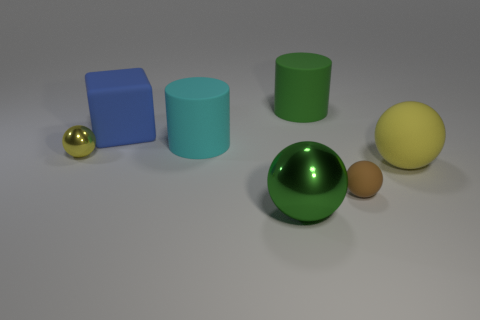How many big objects are either rubber objects or blue rubber things?
Provide a short and direct response. 4. Is there another shiny thing that has the same shape as the green metal object?
Your answer should be compact. Yes. Is the big metallic thing the same shape as the cyan rubber thing?
Make the answer very short. No. There is a small ball that is left of the big cylinder that is left of the green rubber cylinder; what is its color?
Make the answer very short. Yellow. There is a sphere that is the same size as the green shiny thing; what is its color?
Provide a short and direct response. Yellow. How many matte things are either big green cylinders or brown balls?
Provide a succinct answer. 2. How many big rubber cylinders are in front of the small thing behind the brown thing?
Provide a succinct answer. 0. The rubber cylinder that is the same color as the big metallic object is what size?
Your answer should be compact. Large. How many objects are large cyan metallic spheres or large balls on the left side of the small brown rubber thing?
Your answer should be compact. 1. Is there a big cyan block made of the same material as the cyan thing?
Your answer should be very brief. No. 